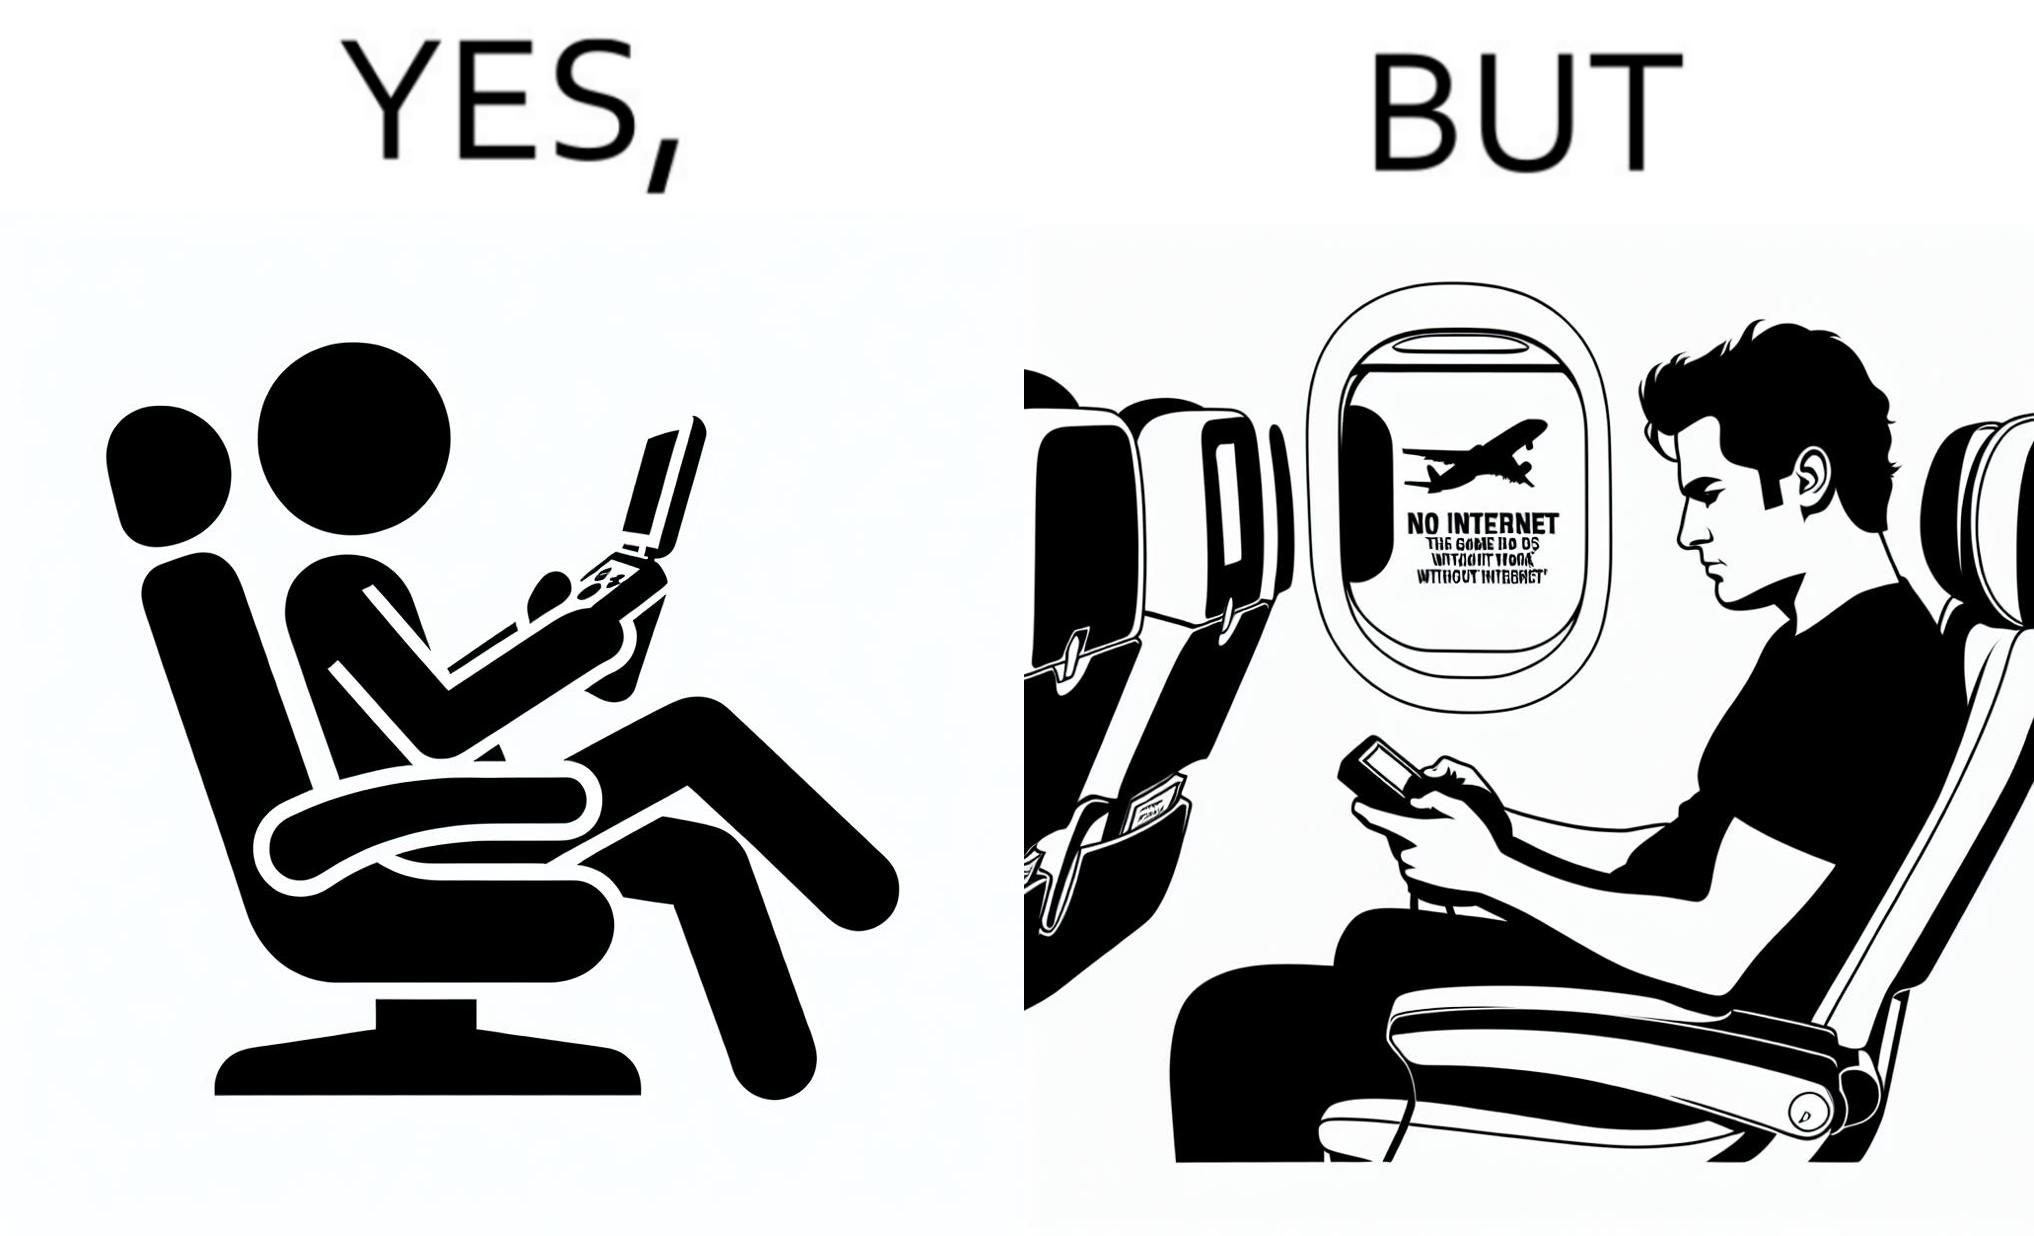Compare the left and right sides of this image. In the left part of the image: a person sitting in a flight seat, with a gaming console in the person's hands. In the right part of the image: a person sitting in a flight seat, with a gaming console in the person's hands, with a message which shows "No Internet, the game does not work without internet". 